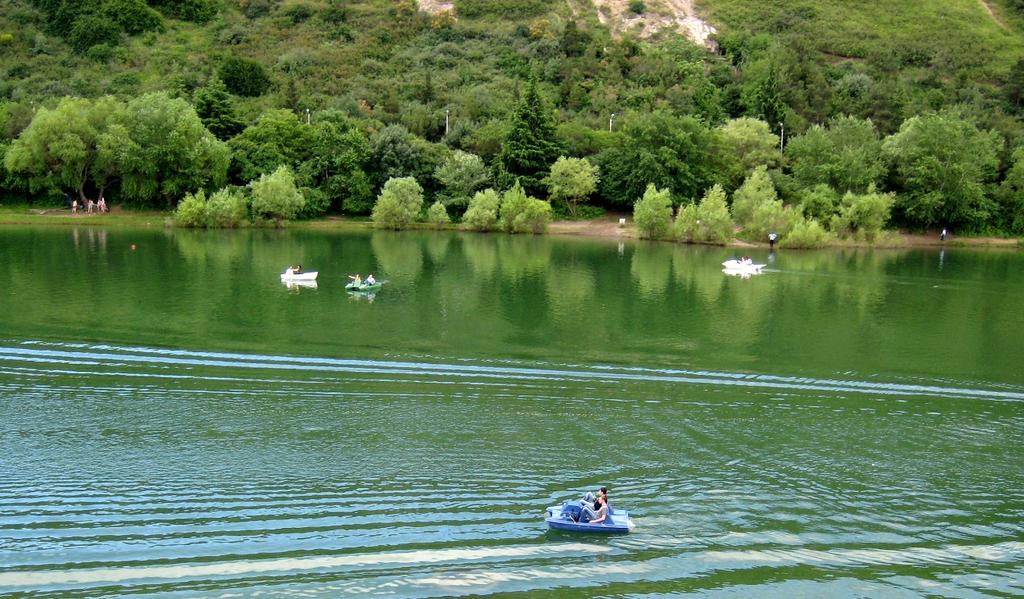What are the persons in the image doing? There are persons sitting in boats and standing on the ground in the image. What type of environment is depicted in the image? There are trees visible in the image, suggesting a natural setting. What other objects or features can be seen in the image? There are rocks in the image. What type of harmony can be heard in the image? There is no audible sound in the image, so it is not possible to determine the type of harmony present. 